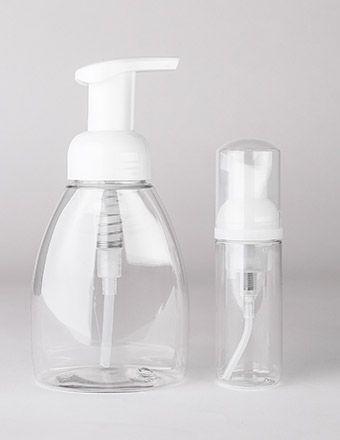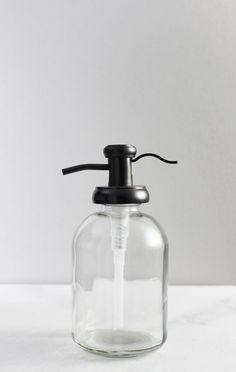The first image is the image on the left, the second image is the image on the right. Given the left and right images, does the statement "One image shows a single pump-top dispenser, which is opaque white and has a left-facing nozzle." hold true? Answer yes or no. No. The first image is the image on the left, the second image is the image on the right. Evaluate the accuracy of this statement regarding the images: "There are more containers in the image on the left.". Is it true? Answer yes or no. Yes. 